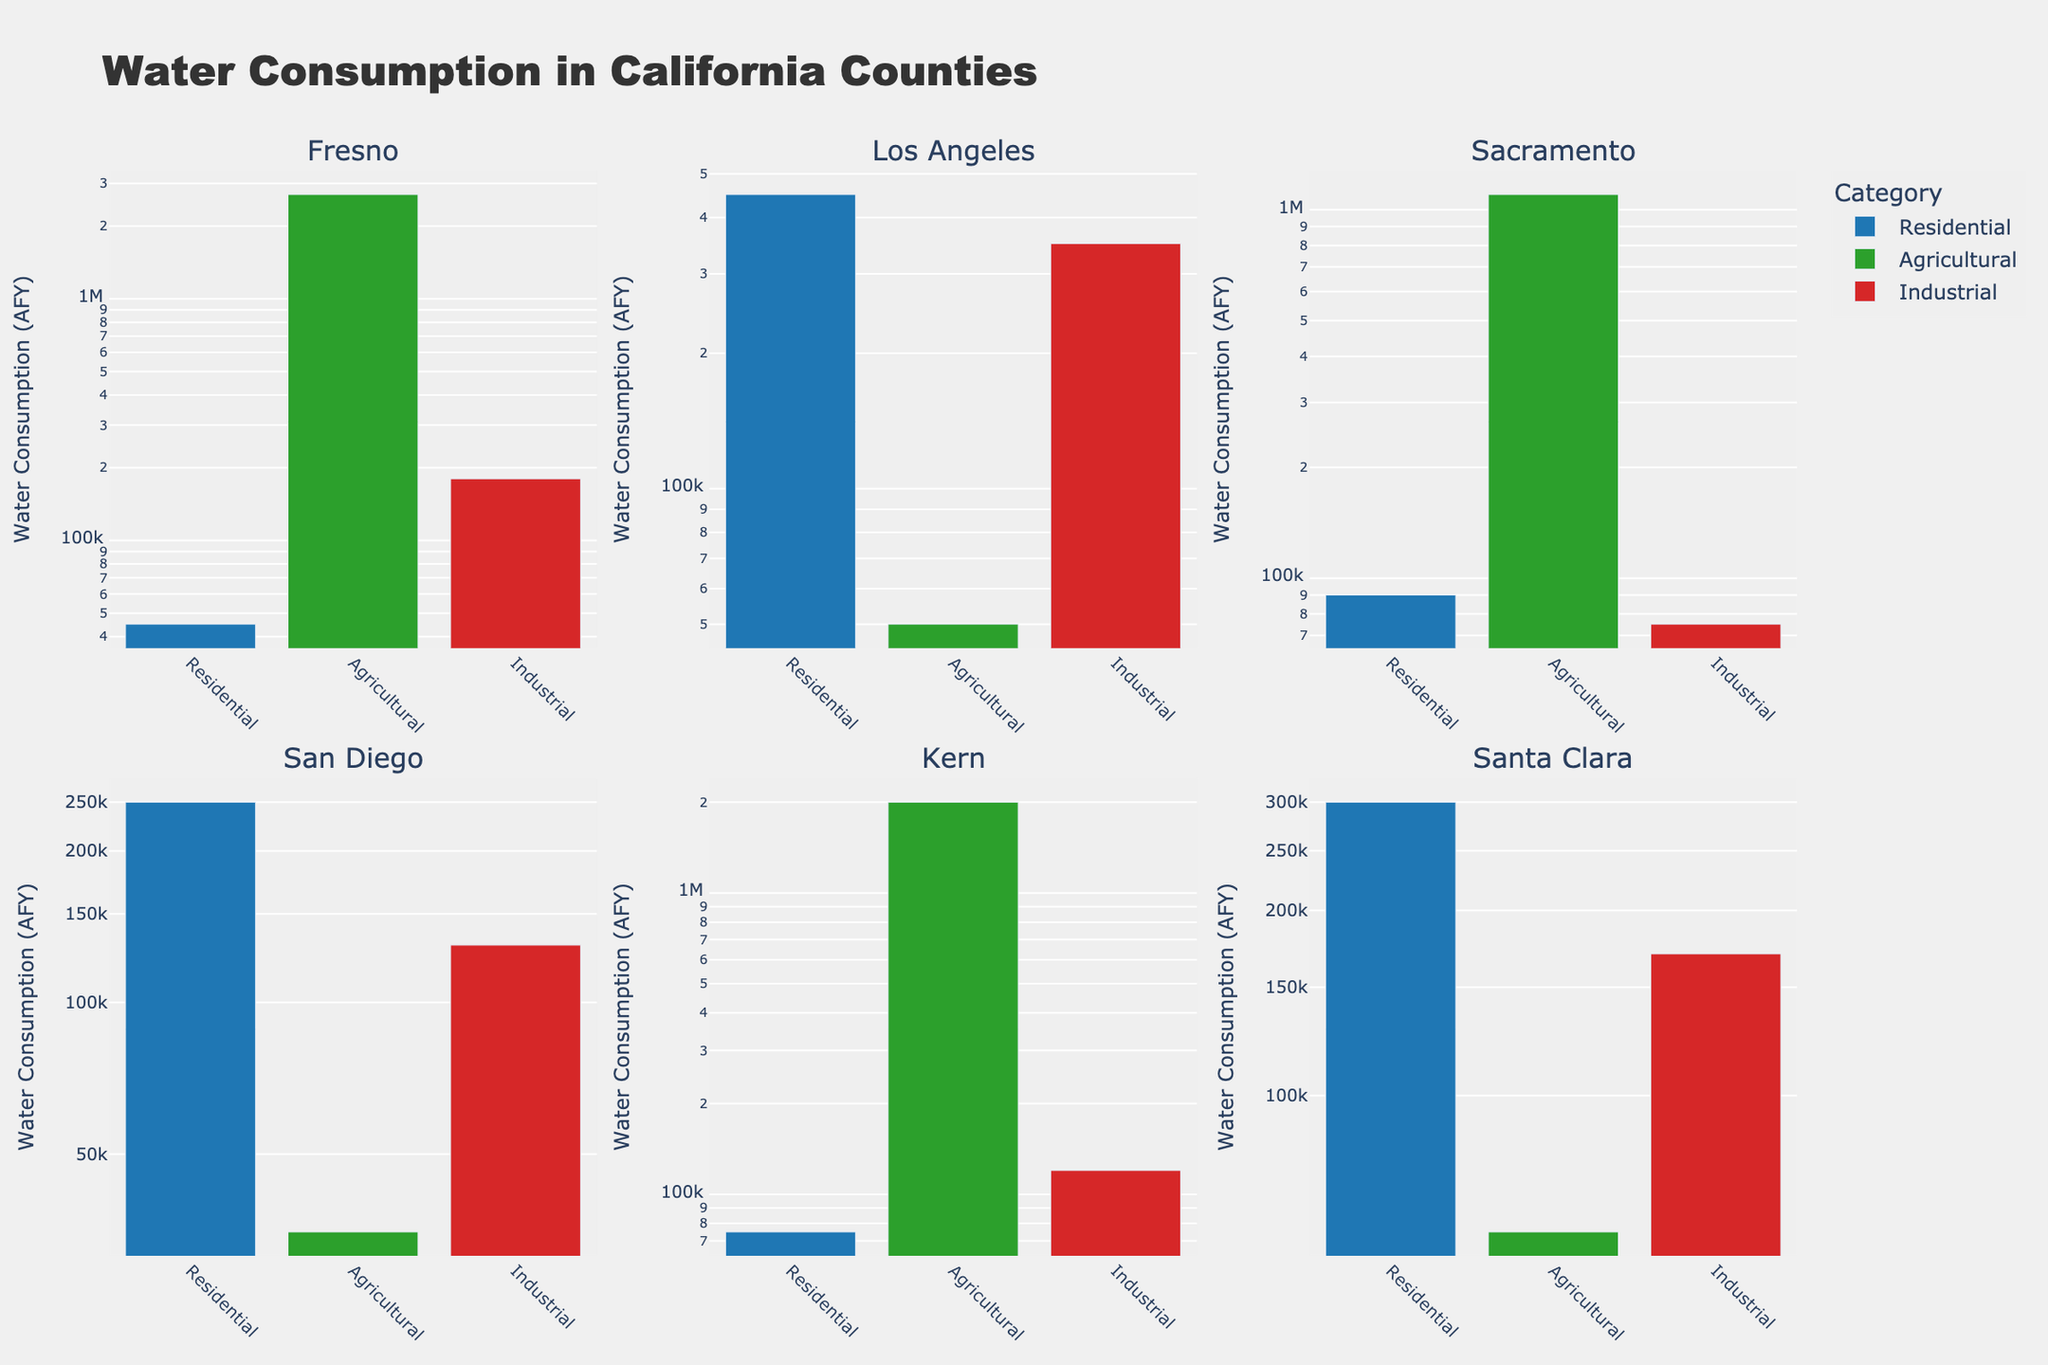How many counties are represented in the figure? The figure has six subplots, each representing a different county: Fresno, Los Angeles, Sacramento, San Diego, Kern, and Santa Clara.
Answer: 6 Which county has the highest residential water consumption? Looking at the bar heights (or values) for Residential water consumption across all subplots, Los Angeles County has the tallest bar for Residential use.
Answer: Los Angeles Is agricultural water consumption in Fresno higher than in Kern? Both subplots for Fresno and Kern show the Agricultural bar; the height is much taller in Fresno (2,700,000 AFY) compared to Kern (2,000,000 AFY).
Answer: Yes What is the primary color used for representing industrial water consumption in the subplots? All bars representing Industrial water consumption are colored in a distinct shade of red.
Answer: Red What is the sum of agricultural water consumption across all counties? Add all Agricultural water consumption values (Fresno: 2,700,000, Los Angeles: 50,000, Sacramento: 1,100,000, San Diego: 35,000, Kern: 2,000,000, Santa Clara: 60,000): \(2,700,000 + 50,000 + 1,100,000 + 35,000 + 2,000,000 + 60,000 = 5,945,000\) AFY.
Answer: 5,945,000 Which county has the lowest total water consumption across all categories? By summing Residential, Agricultural, and Industrial use for each county and comparing: Fresno (2,850,000), Los Angeles (850,000), Sacramento (1,265,000), San Diego (415,000), Kern (2,195,000), Santa Clara (530,000). San Diego has the lowest total: 415,000 AFY.
Answer: San Diego By what factor is residential water consumption in Los Angeles greater than in Fresno? Residential consumption in Los Angeles is 450,000 AFY and in Fresno is 45,000 AFY. The factor is \(450,000 / 45,000 = 10\).
Answer: 10 What is the difference between the highest and the lowest industrial water consumption values among all counties? The highest industrial consumption is in Los Angeles (350,000 AFY), and the lowest is in Sacramento (75,000 AFY). The difference is \(350,000 - 75,000 = 275,000\) AFY.
Answer: 275,000 Which category has the most consistent water consumption across all counties? By visually comparing the bar heights across all subplots, Residential use appears to have more consistent, uniform bars compared to the others.
Answer: Residential 